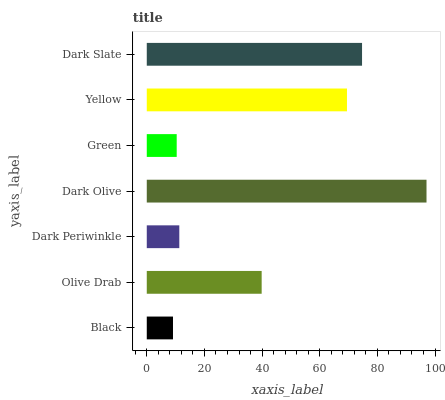Is Black the minimum?
Answer yes or no. Yes. Is Dark Olive the maximum?
Answer yes or no. Yes. Is Olive Drab the minimum?
Answer yes or no. No. Is Olive Drab the maximum?
Answer yes or no. No. Is Olive Drab greater than Black?
Answer yes or no. Yes. Is Black less than Olive Drab?
Answer yes or no. Yes. Is Black greater than Olive Drab?
Answer yes or no. No. Is Olive Drab less than Black?
Answer yes or no. No. Is Olive Drab the high median?
Answer yes or no. Yes. Is Olive Drab the low median?
Answer yes or no. Yes. Is Black the high median?
Answer yes or no. No. Is Green the low median?
Answer yes or no. No. 